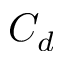<formula> <loc_0><loc_0><loc_500><loc_500>C _ { d }</formula> 